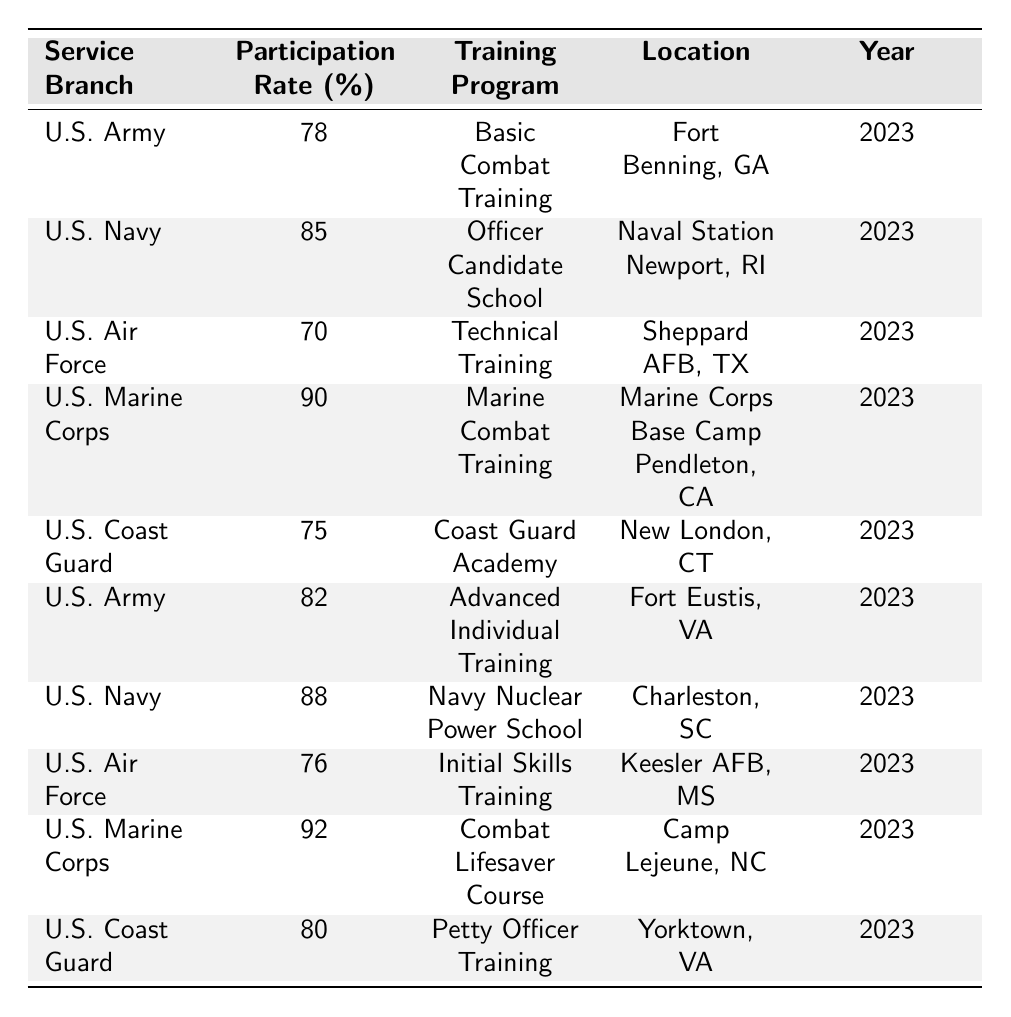What is the participation rate for the U.S. Army in Basic Combat Training? The table lists the U.S. Army’s participation rate for Basic Combat Training as 78%.
Answer: 78% Which service branch has the highest participation rate in 2023? The U.S. Marine Corps has the highest participation rate of 90% for Marine Combat Training in 2023.
Answer: U.S. Marine Corps What is the location of the Navy Nuclear Power School? According to the table, the Navy Nuclear Power School is located at Charleston, SC.
Answer: Charleston, SC What is the average participation rate across all service branches listed? The participation rates are 78, 85, 70, 90, 75, 82, 88, 76, 92, and 80. The sum of these rates is  78 + 85 + 70 + 90 + 75 + 82 + 88 + 76 + 92 + 80 =  834. There are 10 service branches, so the average participation rate is 834 / 10 = 83.4.
Answer: 83.4 Is the participation rate for the U.S. Air Force higher in Technical Training compared to Initial Skills Training? The participation rate for Technical Training is 70%, while for Initial Skills Training, it is 76%. Since 76% is greater than 70%, the statement is false.
Answer: No What two training programs have participation rates above 90%? The table shows that the U.S. Marine Corps has a participation rate of 90% for Marine Combat Training and 92% for the Combat Lifesaver Course, both above 90%.
Answer: Marine Combat Training and Combat Lifesaver Course Which service branch has a training program at Fort Eustis, VA? The U.S. Army has the Advanced Individual Training program located at Fort Eustis, VA according to the table.
Answer: U.S. Army What is the difference in participation rates between the U.S. Navy and the U.S. Coast Guard? The U.S. Navy has a participation rate of 85% and the U.S. Coast Guard has 75%. The difference is 85% - 75% = 10%.
Answer: 10% How do participation rates compare between the U.S. Army programs listed? The U.S. Army has participation rates of 78% for Basic Combat Training and 82% for Advanced Individual Training. Advanced Individual Training is higher by 82% - 78% = 4%.
Answer: 4% What are the locations for the U.S. Air Force training programs listed? The table specifies that the U.S. Air Force conducts Technical Training at Sheppard AFB, TX and Initial Skills Training at Keesler AFB, MS.
Answer: Sheppard AFB, TX and Keesler AFB, MS 